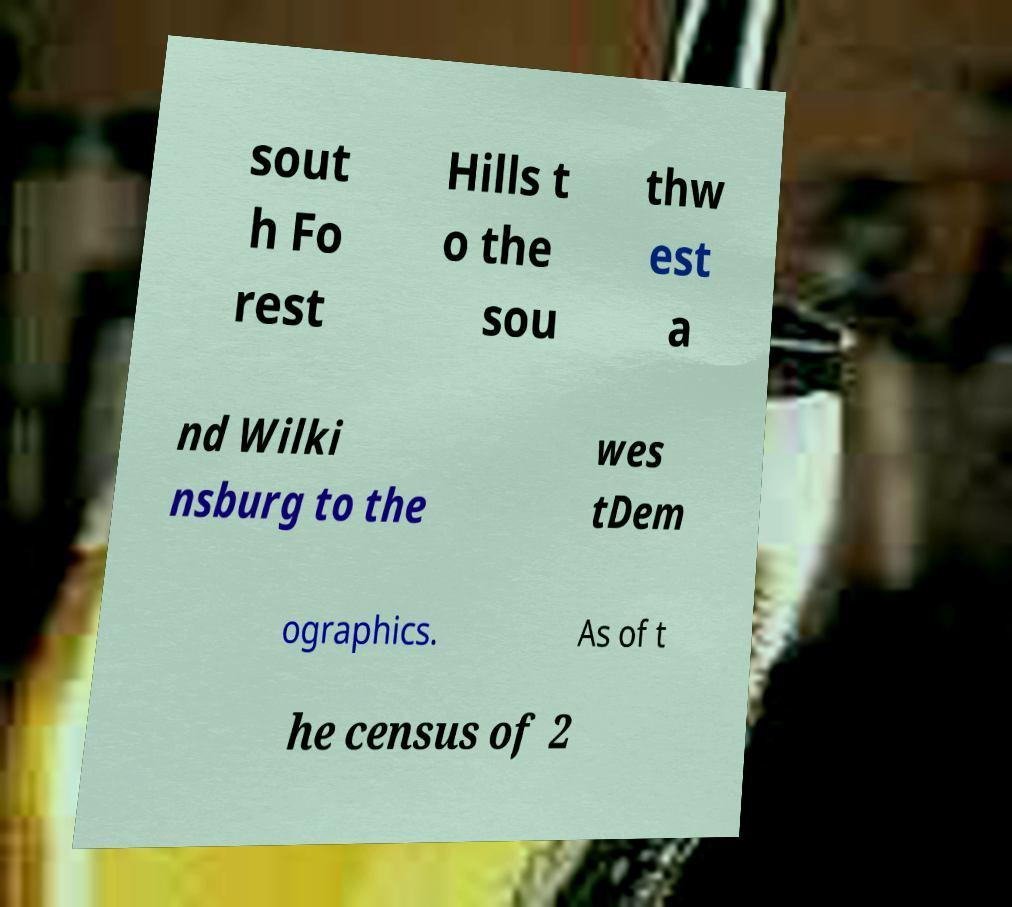Please identify and transcribe the text found in this image. sout h Fo rest Hills t o the sou thw est a nd Wilki nsburg to the wes tDem ographics. As of t he census of 2 